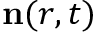Convert formula to latex. <formula><loc_0><loc_0><loc_500><loc_500>n ( r , t )</formula> 